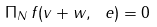<formula> <loc_0><loc_0><loc_500><loc_500>\Pi _ { N } \, f ( v + w , \ e ) = 0</formula> 